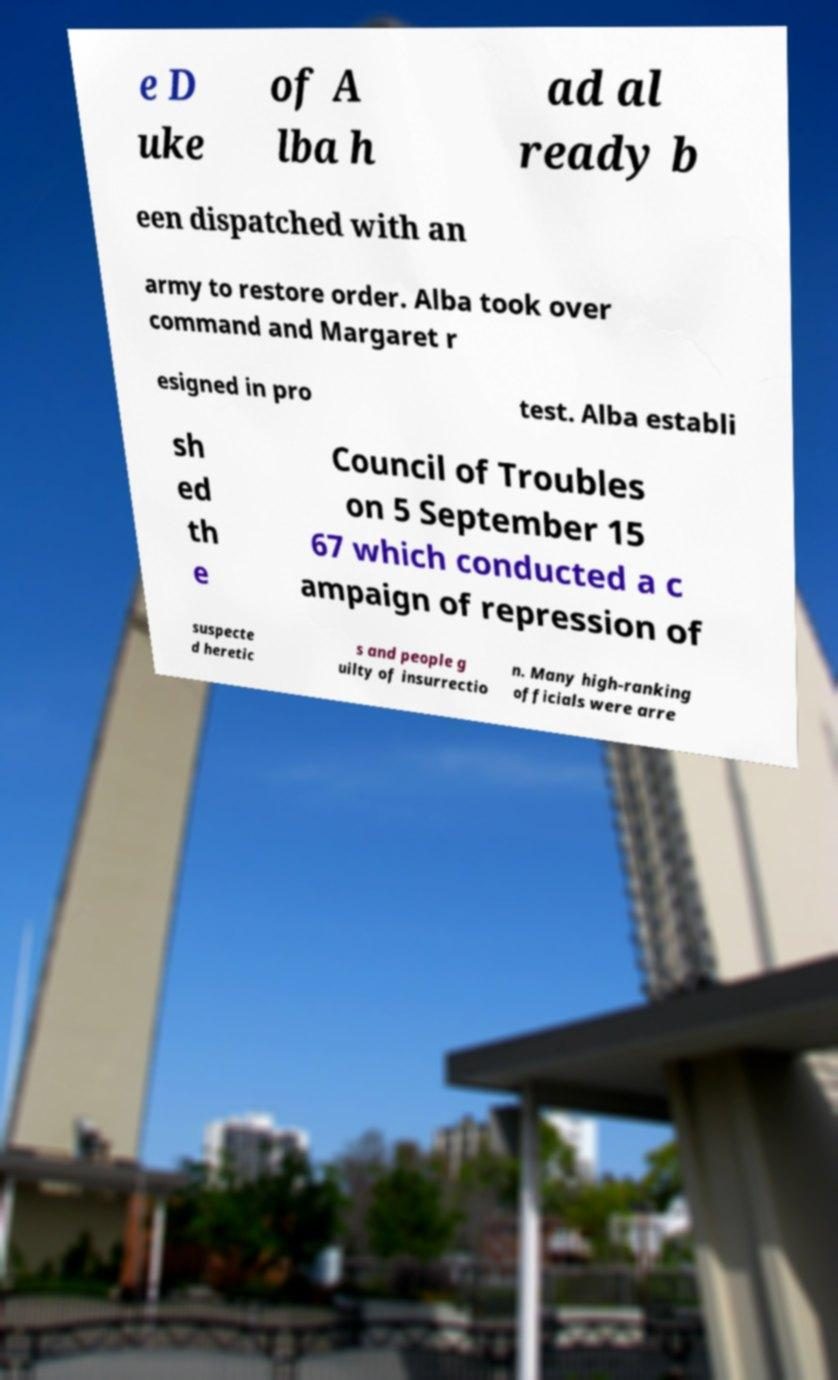Can you accurately transcribe the text from the provided image for me? e D uke of A lba h ad al ready b een dispatched with an army to restore order. Alba took over command and Margaret r esigned in pro test. Alba establi sh ed th e Council of Troubles on 5 September 15 67 which conducted a c ampaign of repression of suspecte d heretic s and people g uilty of insurrectio n. Many high-ranking officials were arre 